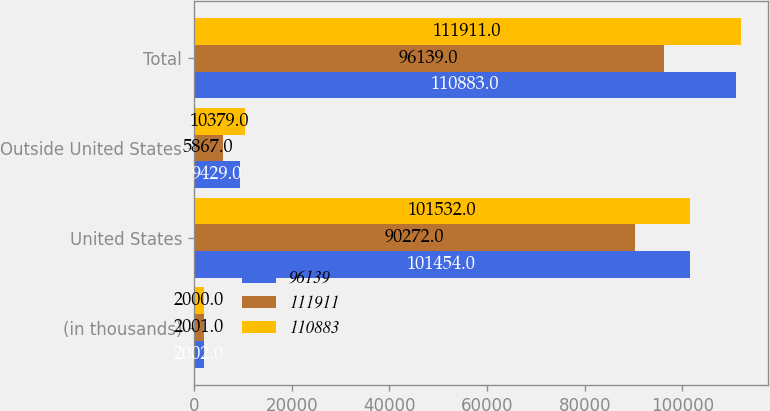Convert chart to OTSL. <chart><loc_0><loc_0><loc_500><loc_500><stacked_bar_chart><ecel><fcel>(in thousands)<fcel>United States<fcel>Outside United States<fcel>Total<nl><fcel>96139<fcel>2002<fcel>101454<fcel>9429<fcel>110883<nl><fcel>111911<fcel>2001<fcel>90272<fcel>5867<fcel>96139<nl><fcel>110883<fcel>2000<fcel>101532<fcel>10379<fcel>111911<nl></chart> 